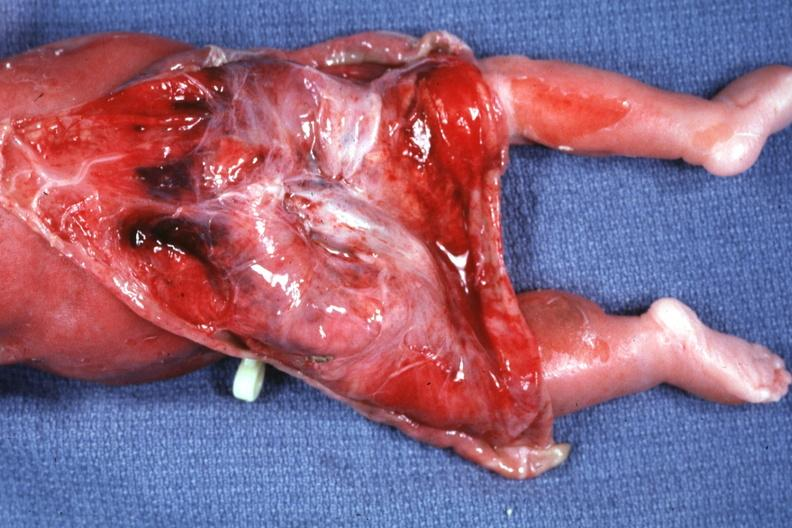does retroperitoneal liposarcoma show skin over back a buttocks reflected to show large tumor mass?
Answer the question using a single word or phrase. No 